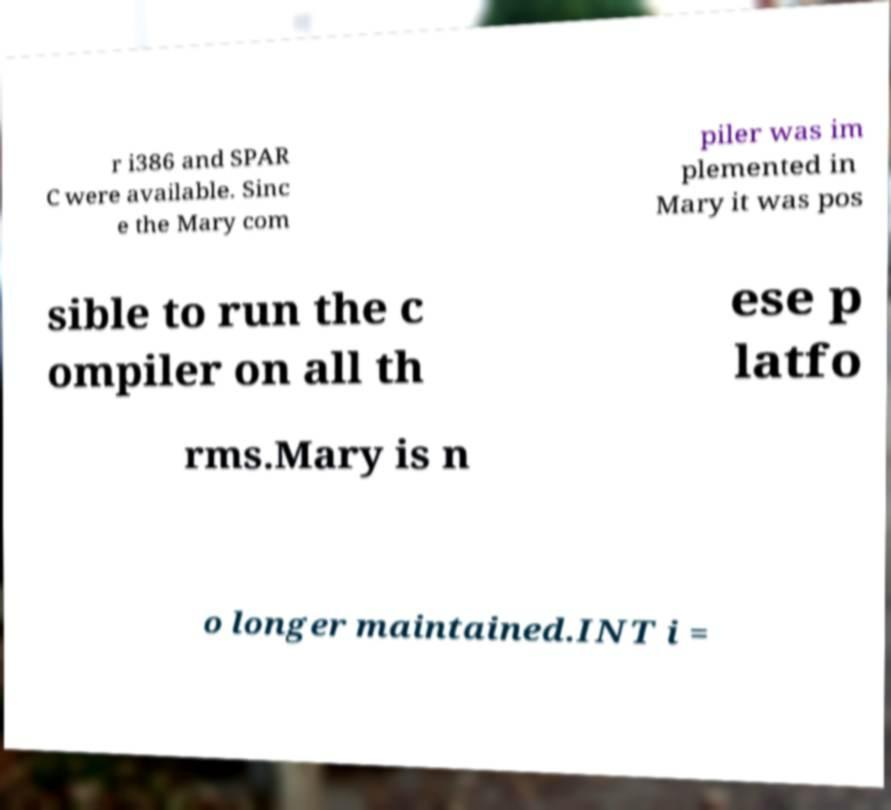There's text embedded in this image that I need extracted. Can you transcribe it verbatim? r i386 and SPAR C were available. Sinc e the Mary com piler was im plemented in Mary it was pos sible to run the c ompiler on all th ese p latfo rms.Mary is n o longer maintained.INT i = 